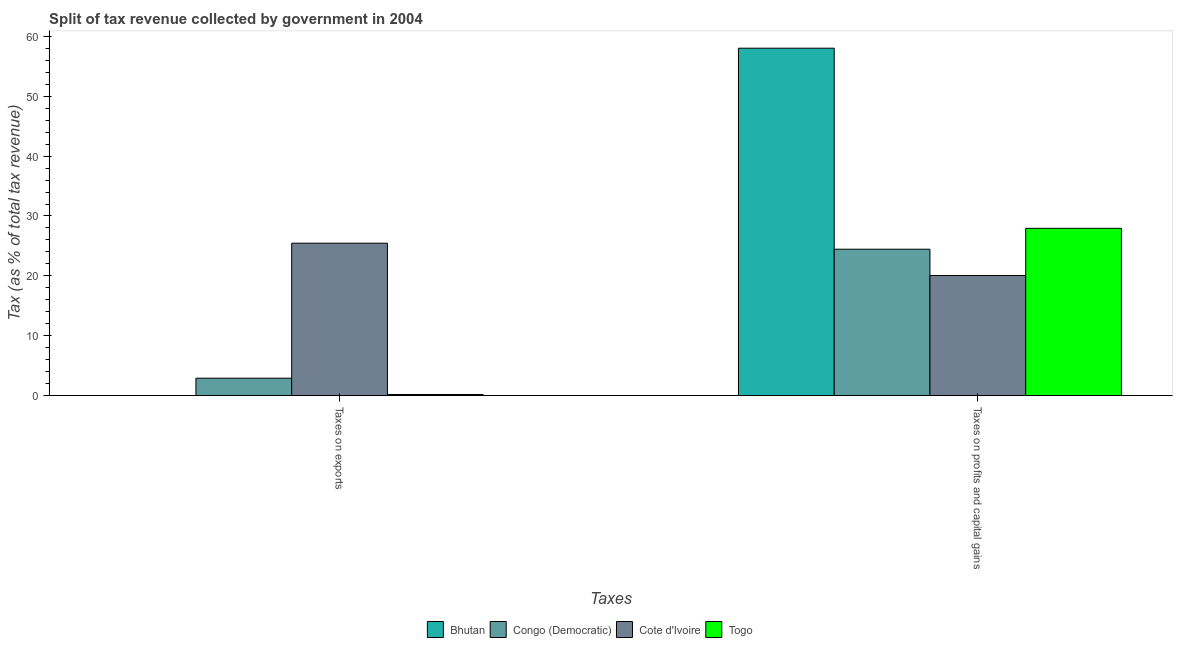How many different coloured bars are there?
Your answer should be compact. 4. Are the number of bars on each tick of the X-axis equal?
Keep it short and to the point. Yes. How many bars are there on the 2nd tick from the left?
Provide a succinct answer. 4. What is the label of the 2nd group of bars from the left?
Offer a very short reply. Taxes on profits and capital gains. What is the percentage of revenue obtained from taxes on exports in Bhutan?
Provide a succinct answer. 0.02. Across all countries, what is the maximum percentage of revenue obtained from taxes on profits and capital gains?
Your answer should be very brief. 58.02. Across all countries, what is the minimum percentage of revenue obtained from taxes on profits and capital gains?
Keep it short and to the point. 20.06. In which country was the percentage of revenue obtained from taxes on exports maximum?
Your response must be concise. Cote d'Ivoire. In which country was the percentage of revenue obtained from taxes on profits and capital gains minimum?
Your answer should be compact. Cote d'Ivoire. What is the total percentage of revenue obtained from taxes on profits and capital gains in the graph?
Your answer should be very brief. 130.47. What is the difference between the percentage of revenue obtained from taxes on profits and capital gains in Togo and that in Bhutan?
Your answer should be compact. -30.08. What is the difference between the percentage of revenue obtained from taxes on profits and capital gains in Cote d'Ivoire and the percentage of revenue obtained from taxes on exports in Togo?
Your answer should be compact. 19.87. What is the average percentage of revenue obtained from taxes on exports per country?
Give a very brief answer. 7.15. What is the difference between the percentage of revenue obtained from taxes on profits and capital gains and percentage of revenue obtained from taxes on exports in Bhutan?
Your answer should be compact. 58. What is the ratio of the percentage of revenue obtained from taxes on exports in Congo (Democratic) to that in Cote d'Ivoire?
Your answer should be very brief. 0.11. What does the 1st bar from the left in Taxes on profits and capital gains represents?
Make the answer very short. Bhutan. What does the 3rd bar from the right in Taxes on profits and capital gains represents?
Make the answer very short. Congo (Democratic). How many countries are there in the graph?
Keep it short and to the point. 4. What is the difference between two consecutive major ticks on the Y-axis?
Offer a very short reply. 10. Are the values on the major ticks of Y-axis written in scientific E-notation?
Offer a terse response. No. Where does the legend appear in the graph?
Your answer should be compact. Bottom center. How are the legend labels stacked?
Provide a short and direct response. Horizontal. What is the title of the graph?
Keep it short and to the point. Split of tax revenue collected by government in 2004. Does "United States" appear as one of the legend labels in the graph?
Your response must be concise. No. What is the label or title of the X-axis?
Provide a short and direct response. Taxes. What is the label or title of the Y-axis?
Offer a terse response. Tax (as % of total tax revenue). What is the Tax (as % of total tax revenue) of Bhutan in Taxes on exports?
Your response must be concise. 0.02. What is the Tax (as % of total tax revenue) of Congo (Democratic) in Taxes on exports?
Provide a short and direct response. 2.91. What is the Tax (as % of total tax revenue) in Cote d'Ivoire in Taxes on exports?
Provide a succinct answer. 25.46. What is the Tax (as % of total tax revenue) of Togo in Taxes on exports?
Provide a short and direct response. 0.19. What is the Tax (as % of total tax revenue) in Bhutan in Taxes on profits and capital gains?
Your response must be concise. 58.02. What is the Tax (as % of total tax revenue) in Congo (Democratic) in Taxes on profits and capital gains?
Your answer should be very brief. 24.45. What is the Tax (as % of total tax revenue) in Cote d'Ivoire in Taxes on profits and capital gains?
Provide a short and direct response. 20.06. What is the Tax (as % of total tax revenue) of Togo in Taxes on profits and capital gains?
Keep it short and to the point. 27.94. Across all Taxes, what is the maximum Tax (as % of total tax revenue) in Bhutan?
Give a very brief answer. 58.02. Across all Taxes, what is the maximum Tax (as % of total tax revenue) of Congo (Democratic)?
Your answer should be compact. 24.45. Across all Taxes, what is the maximum Tax (as % of total tax revenue) in Cote d'Ivoire?
Your answer should be very brief. 25.46. Across all Taxes, what is the maximum Tax (as % of total tax revenue) of Togo?
Keep it short and to the point. 27.94. Across all Taxes, what is the minimum Tax (as % of total tax revenue) of Bhutan?
Your response must be concise. 0.02. Across all Taxes, what is the minimum Tax (as % of total tax revenue) of Congo (Democratic)?
Your response must be concise. 2.91. Across all Taxes, what is the minimum Tax (as % of total tax revenue) in Cote d'Ivoire?
Your response must be concise. 20.06. Across all Taxes, what is the minimum Tax (as % of total tax revenue) of Togo?
Your answer should be compact. 0.19. What is the total Tax (as % of total tax revenue) of Bhutan in the graph?
Offer a very short reply. 58.04. What is the total Tax (as % of total tax revenue) of Congo (Democratic) in the graph?
Your response must be concise. 27.37. What is the total Tax (as % of total tax revenue) in Cote d'Ivoire in the graph?
Offer a terse response. 45.51. What is the total Tax (as % of total tax revenue) in Togo in the graph?
Offer a very short reply. 28.13. What is the difference between the Tax (as % of total tax revenue) of Bhutan in Taxes on exports and that in Taxes on profits and capital gains?
Make the answer very short. -58. What is the difference between the Tax (as % of total tax revenue) in Congo (Democratic) in Taxes on exports and that in Taxes on profits and capital gains?
Make the answer very short. -21.54. What is the difference between the Tax (as % of total tax revenue) of Cote d'Ivoire in Taxes on exports and that in Taxes on profits and capital gains?
Keep it short and to the point. 5.4. What is the difference between the Tax (as % of total tax revenue) of Togo in Taxes on exports and that in Taxes on profits and capital gains?
Make the answer very short. -27.75. What is the difference between the Tax (as % of total tax revenue) of Bhutan in Taxes on exports and the Tax (as % of total tax revenue) of Congo (Democratic) in Taxes on profits and capital gains?
Make the answer very short. -24.43. What is the difference between the Tax (as % of total tax revenue) of Bhutan in Taxes on exports and the Tax (as % of total tax revenue) of Cote d'Ivoire in Taxes on profits and capital gains?
Give a very brief answer. -20.04. What is the difference between the Tax (as % of total tax revenue) in Bhutan in Taxes on exports and the Tax (as % of total tax revenue) in Togo in Taxes on profits and capital gains?
Offer a terse response. -27.92. What is the difference between the Tax (as % of total tax revenue) in Congo (Democratic) in Taxes on exports and the Tax (as % of total tax revenue) in Cote d'Ivoire in Taxes on profits and capital gains?
Ensure brevity in your answer.  -17.14. What is the difference between the Tax (as % of total tax revenue) of Congo (Democratic) in Taxes on exports and the Tax (as % of total tax revenue) of Togo in Taxes on profits and capital gains?
Your answer should be very brief. -25.03. What is the difference between the Tax (as % of total tax revenue) in Cote d'Ivoire in Taxes on exports and the Tax (as % of total tax revenue) in Togo in Taxes on profits and capital gains?
Your response must be concise. -2.48. What is the average Tax (as % of total tax revenue) in Bhutan per Taxes?
Your answer should be compact. 29.02. What is the average Tax (as % of total tax revenue) of Congo (Democratic) per Taxes?
Ensure brevity in your answer.  13.68. What is the average Tax (as % of total tax revenue) of Cote d'Ivoire per Taxes?
Make the answer very short. 22.76. What is the average Tax (as % of total tax revenue) in Togo per Taxes?
Give a very brief answer. 14.07. What is the difference between the Tax (as % of total tax revenue) of Bhutan and Tax (as % of total tax revenue) of Congo (Democratic) in Taxes on exports?
Provide a short and direct response. -2.89. What is the difference between the Tax (as % of total tax revenue) of Bhutan and Tax (as % of total tax revenue) of Cote d'Ivoire in Taxes on exports?
Offer a very short reply. -25.44. What is the difference between the Tax (as % of total tax revenue) in Bhutan and Tax (as % of total tax revenue) in Togo in Taxes on exports?
Ensure brevity in your answer.  -0.17. What is the difference between the Tax (as % of total tax revenue) of Congo (Democratic) and Tax (as % of total tax revenue) of Cote d'Ivoire in Taxes on exports?
Offer a very short reply. -22.54. What is the difference between the Tax (as % of total tax revenue) of Congo (Democratic) and Tax (as % of total tax revenue) of Togo in Taxes on exports?
Ensure brevity in your answer.  2.72. What is the difference between the Tax (as % of total tax revenue) in Cote d'Ivoire and Tax (as % of total tax revenue) in Togo in Taxes on exports?
Your answer should be compact. 25.26. What is the difference between the Tax (as % of total tax revenue) in Bhutan and Tax (as % of total tax revenue) in Congo (Democratic) in Taxes on profits and capital gains?
Ensure brevity in your answer.  33.57. What is the difference between the Tax (as % of total tax revenue) of Bhutan and Tax (as % of total tax revenue) of Cote d'Ivoire in Taxes on profits and capital gains?
Keep it short and to the point. 37.96. What is the difference between the Tax (as % of total tax revenue) in Bhutan and Tax (as % of total tax revenue) in Togo in Taxes on profits and capital gains?
Keep it short and to the point. 30.08. What is the difference between the Tax (as % of total tax revenue) of Congo (Democratic) and Tax (as % of total tax revenue) of Cote d'Ivoire in Taxes on profits and capital gains?
Your answer should be compact. 4.39. What is the difference between the Tax (as % of total tax revenue) in Congo (Democratic) and Tax (as % of total tax revenue) in Togo in Taxes on profits and capital gains?
Your response must be concise. -3.49. What is the difference between the Tax (as % of total tax revenue) of Cote d'Ivoire and Tax (as % of total tax revenue) of Togo in Taxes on profits and capital gains?
Provide a short and direct response. -7.88. What is the ratio of the Tax (as % of total tax revenue) in Congo (Democratic) in Taxes on exports to that in Taxes on profits and capital gains?
Make the answer very short. 0.12. What is the ratio of the Tax (as % of total tax revenue) in Cote d'Ivoire in Taxes on exports to that in Taxes on profits and capital gains?
Give a very brief answer. 1.27. What is the ratio of the Tax (as % of total tax revenue) of Togo in Taxes on exports to that in Taxes on profits and capital gains?
Ensure brevity in your answer.  0.01. What is the difference between the highest and the second highest Tax (as % of total tax revenue) in Bhutan?
Provide a short and direct response. 58. What is the difference between the highest and the second highest Tax (as % of total tax revenue) of Congo (Democratic)?
Your response must be concise. 21.54. What is the difference between the highest and the second highest Tax (as % of total tax revenue) of Cote d'Ivoire?
Keep it short and to the point. 5.4. What is the difference between the highest and the second highest Tax (as % of total tax revenue) of Togo?
Your answer should be very brief. 27.75. What is the difference between the highest and the lowest Tax (as % of total tax revenue) of Bhutan?
Keep it short and to the point. 58. What is the difference between the highest and the lowest Tax (as % of total tax revenue) of Congo (Democratic)?
Ensure brevity in your answer.  21.54. What is the difference between the highest and the lowest Tax (as % of total tax revenue) in Cote d'Ivoire?
Provide a succinct answer. 5.4. What is the difference between the highest and the lowest Tax (as % of total tax revenue) of Togo?
Your answer should be compact. 27.75. 